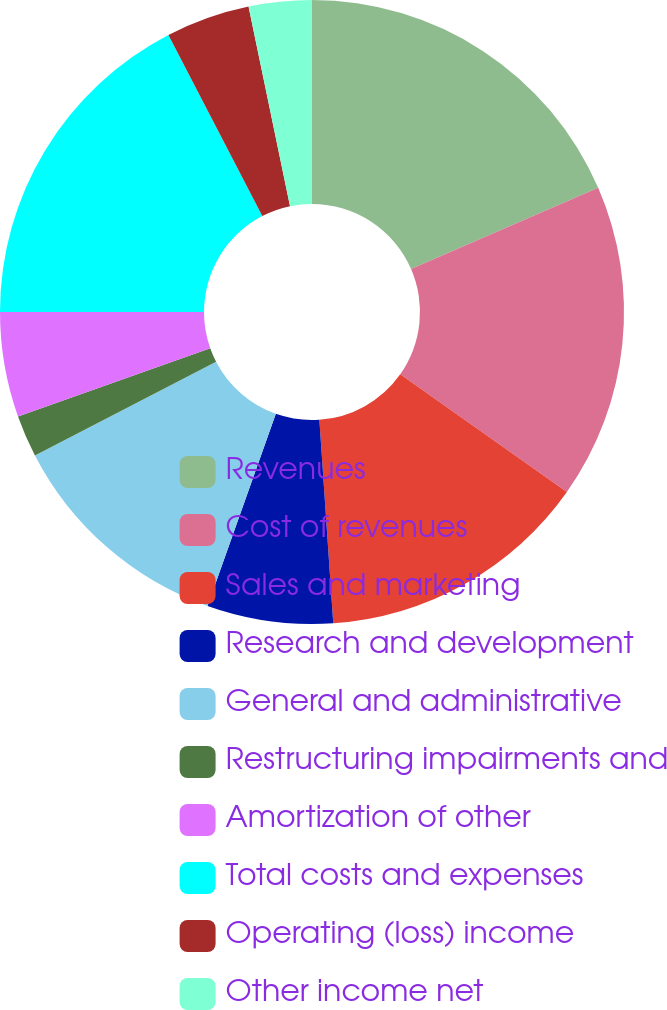<chart> <loc_0><loc_0><loc_500><loc_500><pie_chart><fcel>Revenues<fcel>Cost of revenues<fcel>Sales and marketing<fcel>Research and development<fcel>General and administrative<fcel>Restructuring impairments and<fcel>Amortization of other<fcel>Total costs and expenses<fcel>Operating (loss) income<fcel>Other income net<nl><fcel>18.48%<fcel>16.3%<fcel>14.13%<fcel>6.52%<fcel>11.96%<fcel>2.17%<fcel>5.43%<fcel>17.39%<fcel>4.35%<fcel>3.26%<nl></chart> 